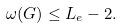Convert formula to latex. <formula><loc_0><loc_0><loc_500><loc_500>\omega ( G ) \leq L _ { e } - 2 .</formula> 